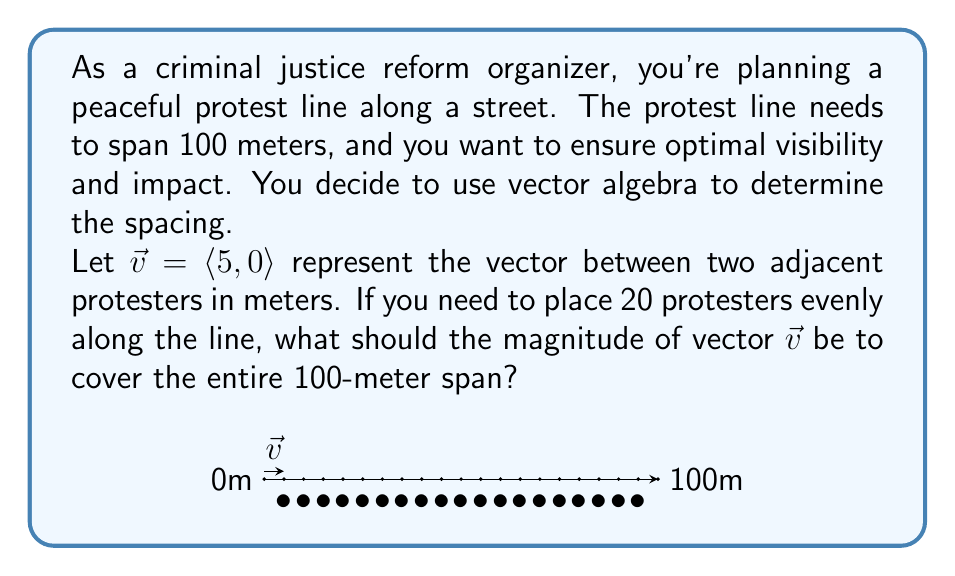Give your solution to this math problem. Let's approach this step-by-step:

1) First, we need to understand what the question is asking. We need to find the magnitude of vector $\vec{v}$ that, when repeated 19 times (for 20 protesters), spans 100 meters.

2) Let's call the magnitude of $\vec{v}$ as $|\vec{v}|$. We know that:
   $$19 \cdot |\vec{v}| = 100$$

3) This is because there are 19 spaces between 20 protesters.

4) Now we can solve for $|\vec{v}|$:
   $$|\vec{v}| = \frac{100}{19}$$

5) Calculate this:
   $$|\vec{v}| = 5.2631... \approx 5.26 \text{ meters}$$

6) Now, we need to adjust our vector $\vec{v}$. Currently, it's $\langle 5, 0 \rangle$, but we need it to be $\langle 5.26, 0 \rangle$.

7) The magnitude of a 2D vector $\langle x, y \rangle$ is given by $\sqrt{x^2 + y^2}$. In our case, $y = 0$, so the magnitude is simply $x$.

Therefore, the vector $\vec{v}$ should be $\langle 5.26, 0 \rangle$ to ensure even spacing of 20 protesters over 100 meters.
Answer: $|\vec{v}| = 5.26$ meters 